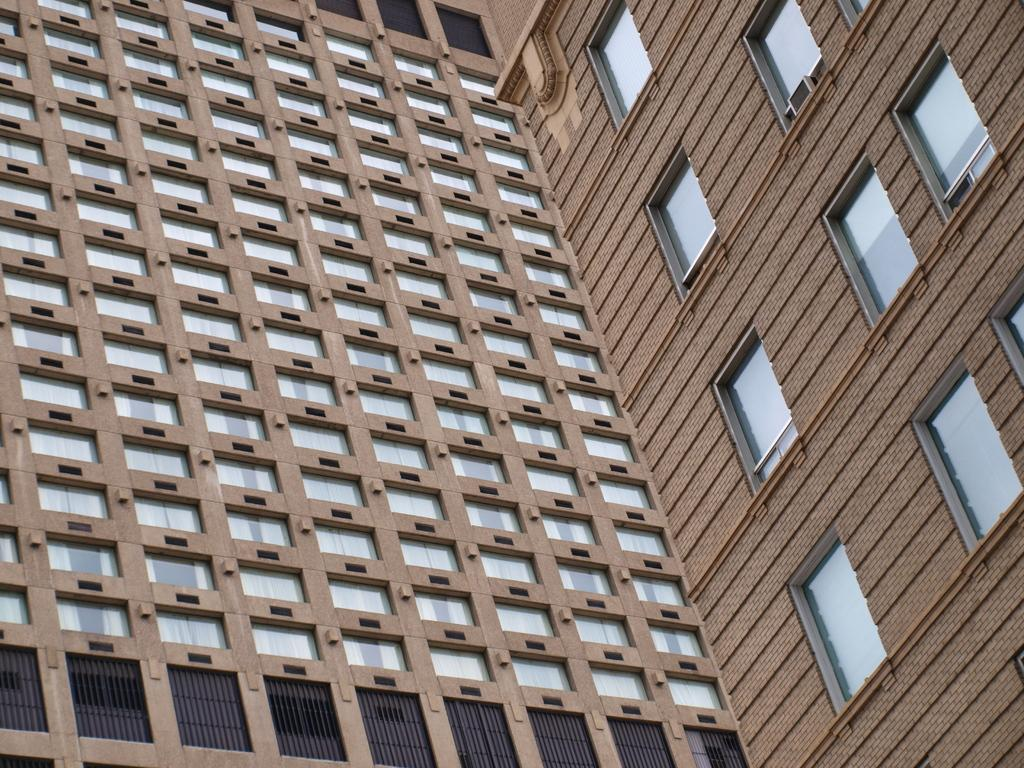What is the main structure in the image? There is a big building in the image. What is the color of the building? The building is brown in color. What features can be seen on the building? The building has windows and glasses. What part of the building is visible in the image? The entire building is visible in the image, as it is the main subject. What level of the building is shown in the image? The image does not specify a particular level of the building; it shows the entire structure. 